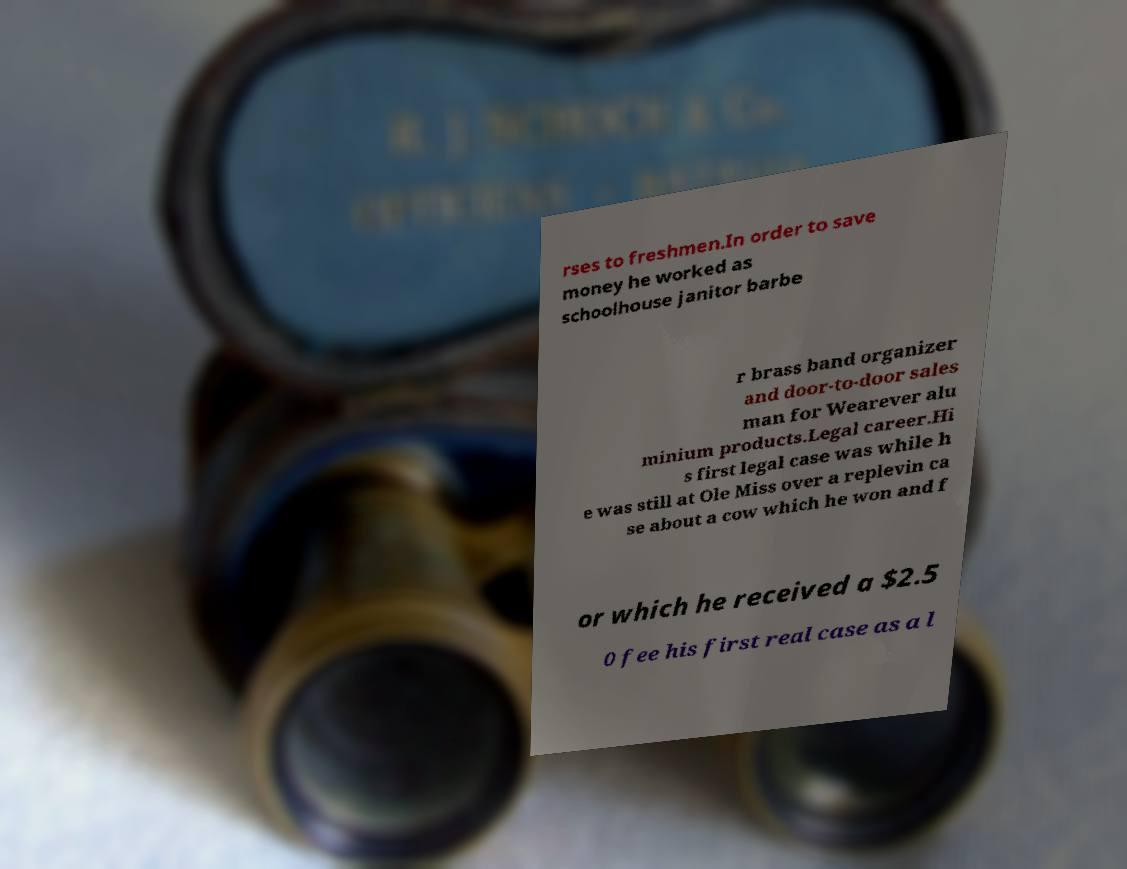There's text embedded in this image that I need extracted. Can you transcribe it verbatim? rses to freshmen.In order to save money he worked as schoolhouse janitor barbe r brass band organizer and door-to-door sales man for Wearever alu minium products.Legal career.Hi s first legal case was while h e was still at Ole Miss over a replevin ca se about a cow which he won and f or which he received a $2.5 0 fee his first real case as a l 